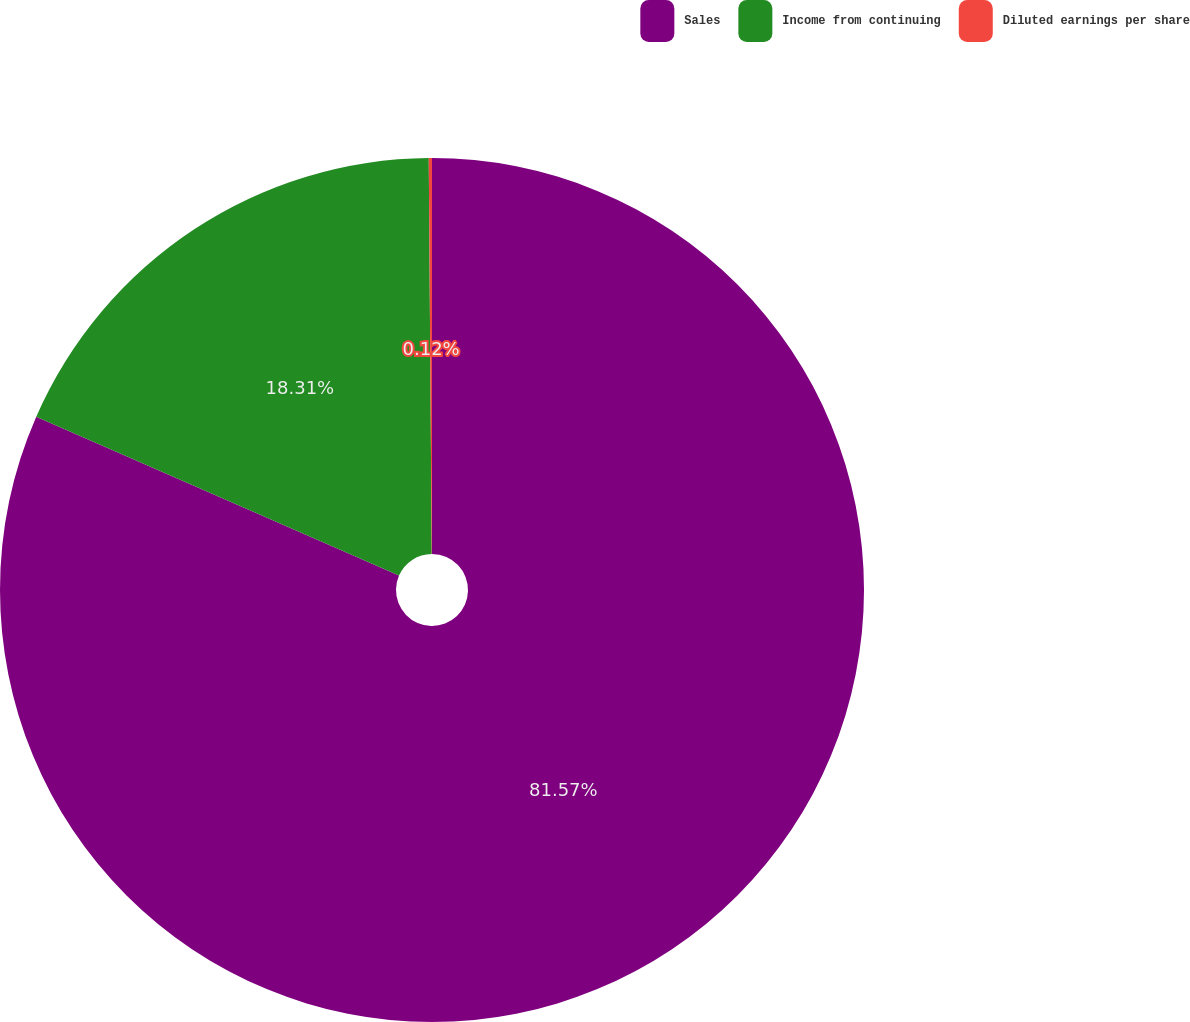<chart> <loc_0><loc_0><loc_500><loc_500><pie_chart><fcel>Sales<fcel>Income from continuing<fcel>Diluted earnings per share<nl><fcel>81.56%<fcel>18.31%<fcel>0.12%<nl></chart> 